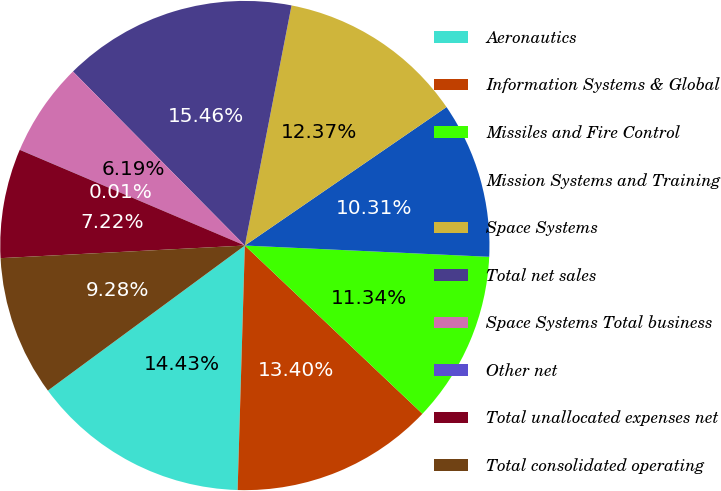Convert chart. <chart><loc_0><loc_0><loc_500><loc_500><pie_chart><fcel>Aeronautics<fcel>Information Systems & Global<fcel>Missiles and Fire Control<fcel>Mission Systems and Training<fcel>Space Systems<fcel>Total net sales<fcel>Space Systems Total business<fcel>Other net<fcel>Total unallocated expenses net<fcel>Total consolidated operating<nl><fcel>14.43%<fcel>13.4%<fcel>11.34%<fcel>10.31%<fcel>12.37%<fcel>15.46%<fcel>6.19%<fcel>0.01%<fcel>7.22%<fcel>9.28%<nl></chart> 